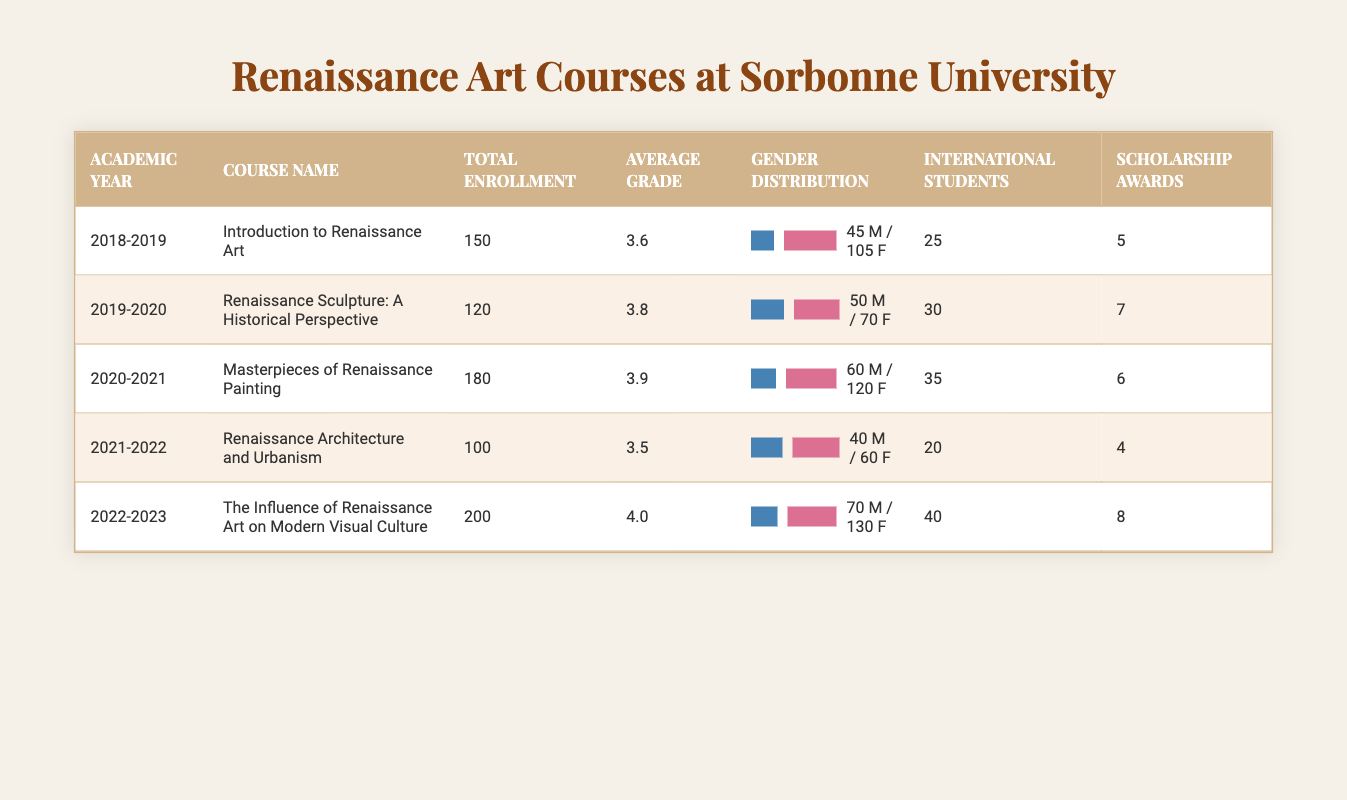What was the total enrollment for the course "Introduction to Renaissance Art" in the academic year 2018-2019? The table indicates that the total enrollment for "Introduction to Renaissance Art" during the academic year 2018-2019 was 150 students.
Answer: 150 How many scholarship awards were given in the academic year 2022-2023? According to the table, in the academic year 2022-2023, there were 8 scholarship awards given.
Answer: 8 What was the average grade for the course "Renaissance Sculpture: A Historical Perspective"? The table shows that the average grade for "Renaissance Sculpture: A Historical Perspective" was 3.8.
Answer: 3.8 Which course had the highest total enrollment over the five years? By examining the table, the course "The Influence of Renaissance Art on Modern Visual Culture" in the academic year 2022-2023 had the highest enrollment with 200 students.
Answer: 200 What was the total number of international students enrolled over the five years? To find the total number of international students, sum the international students from each year: 25 + 30 + 35 + 20 + 40 = 150.
Answer: 150 Which academic year had the lowest total enrollment? The table reveals that the academic year 2021-2022, with a total enrollment of 100 students for the course "Renaissance Architecture and Urbanism," had the lowest enrollment.
Answer: 100 How many more female students were enrolled than male students in the course "Masterpieces of Renaissance Painting"? For "Masterpieces of Renaissance Painting," there were 120 female students and 60 male students, leading to 120 - 60 = 60 more female students enrolled than male students.
Answer: 60 Was the average grade for the course "Renaissance Architecture and Urbanism" above 3.5? The average grade for "Renaissance Architecture and Urbanism" is listed as 3.5, which means it was not above 3.5. Therefore, the answer is no.
Answer: No What was the total number of male and female students in the course "The Influence of Renaissance Art on Modern Visual Culture"? The table shows that there were 70 male and 130 female students enrolled in "The Influence of Renaissance Art on Modern Visual Culture," giving a total of 70 + 130 = 200 students.
Answer: 200 Which course had more scholarship awards, "Masterpieces of Renaissance Painting" or "Renaissance Sculpture: A Historical Perspective"? The table indicates that "Masterpieces of Renaissance Painting" received 6 scholarship awards while "Renaissance Sculpture: A Historical Perspective" received 7. Since 7 is greater than 6, "Renaissance Sculpture: A Historical Perspective" had more scholarship awards.
Answer: "Renaissance Sculpture: A Historical Perspective" 